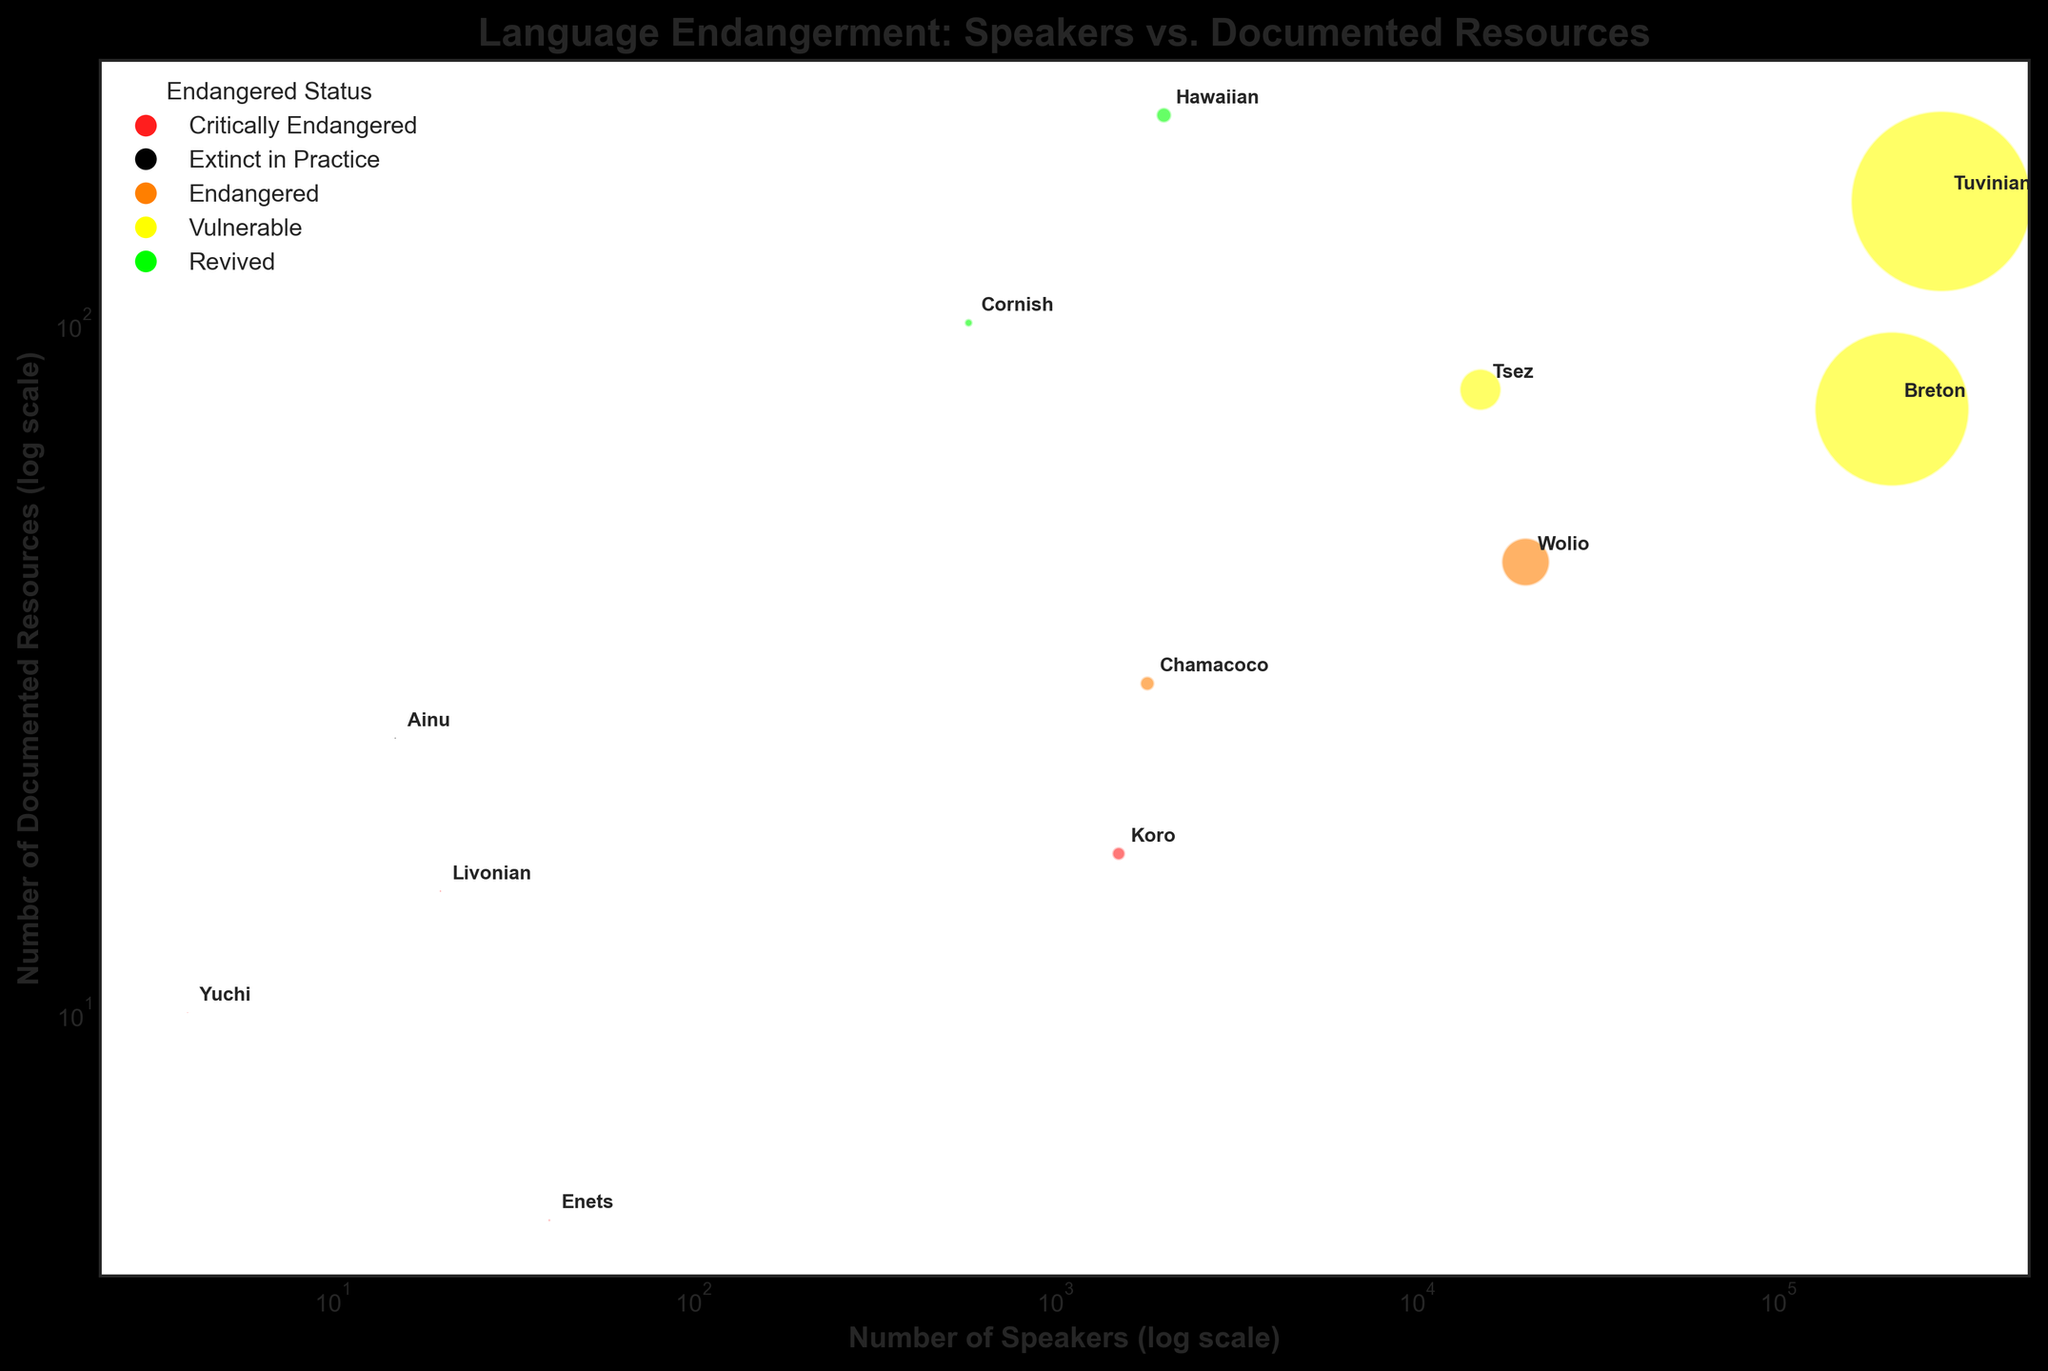What is the title of the plot? The title of the plot is at the top of the figure, shown in bold font. It gives an overview of what the figure is about.
Answer: Language Endangerment: Speakers vs. Documented Resources How many languages are represented in the plot? Count each language label annotated next to the bubbles in the plot. This indicates how many different languages are represented.
Answer: 12 Which language has the smallest number of speakers, and what is its endangered status? Identify the smallest bubble size and then check the corresponding label and color to find the language and its status.
Answer: Yuchi, Critically Endangered What is the relationship between the number of speakers and the number of documented resources for Cornish? Check the position of the Cornish label on the plot. Note the x-axis (number of speakers, log scale) and the y-axis (number of documented resources, log scale).
Answer: Cornish has 577 speakers and 100 documented resources Which language has the highest number of documented resources? Look for the highest position along the y-axis. Find the corresponding language label next to that bubble.
Answer: Hawaiian Compare the number of speakers of Tuvinian and Breton. Which one has more? Check the x-axis position of both Tuvinian and Breton labels. The one further to the right has more speakers.
Answer: Tuvinian Calculate the average number of documented resources for languages that are labeled as "Critically Endangered." Find all bubbles labeled as "Critically Endangered," sum their documented resources and divide by the number of such languages.
Answer: (17 + 10 + 15 + 5) / 4 = 47 / 4 = 11.75 Which language has the largest bubble, and what does this represent? Identify the largest bubble in size and read the corresponding label to find the language. Larger bubbles represent a higher number of speakers.
Answer: Tuvinian, representing 282,000 speakers What can be inferred about the relationship between the number of speakers and the endangered status of a language? Observe the distribution of bubble sizes and colors. Smaller bubbles (fewer speakers) are often more critically endangered. Larger bubbles (more speakers) tend to be less endangered or vulnerable.
Answer: Generally, languages with fewer speakers are more critically endangered Which languages are classified as "Vulnerable," and how many are there? Identify the bubbles colored in yellow according to the color map, and count how many of them there are.
Answer: Tuvinian, Breton, Tsez; 3 